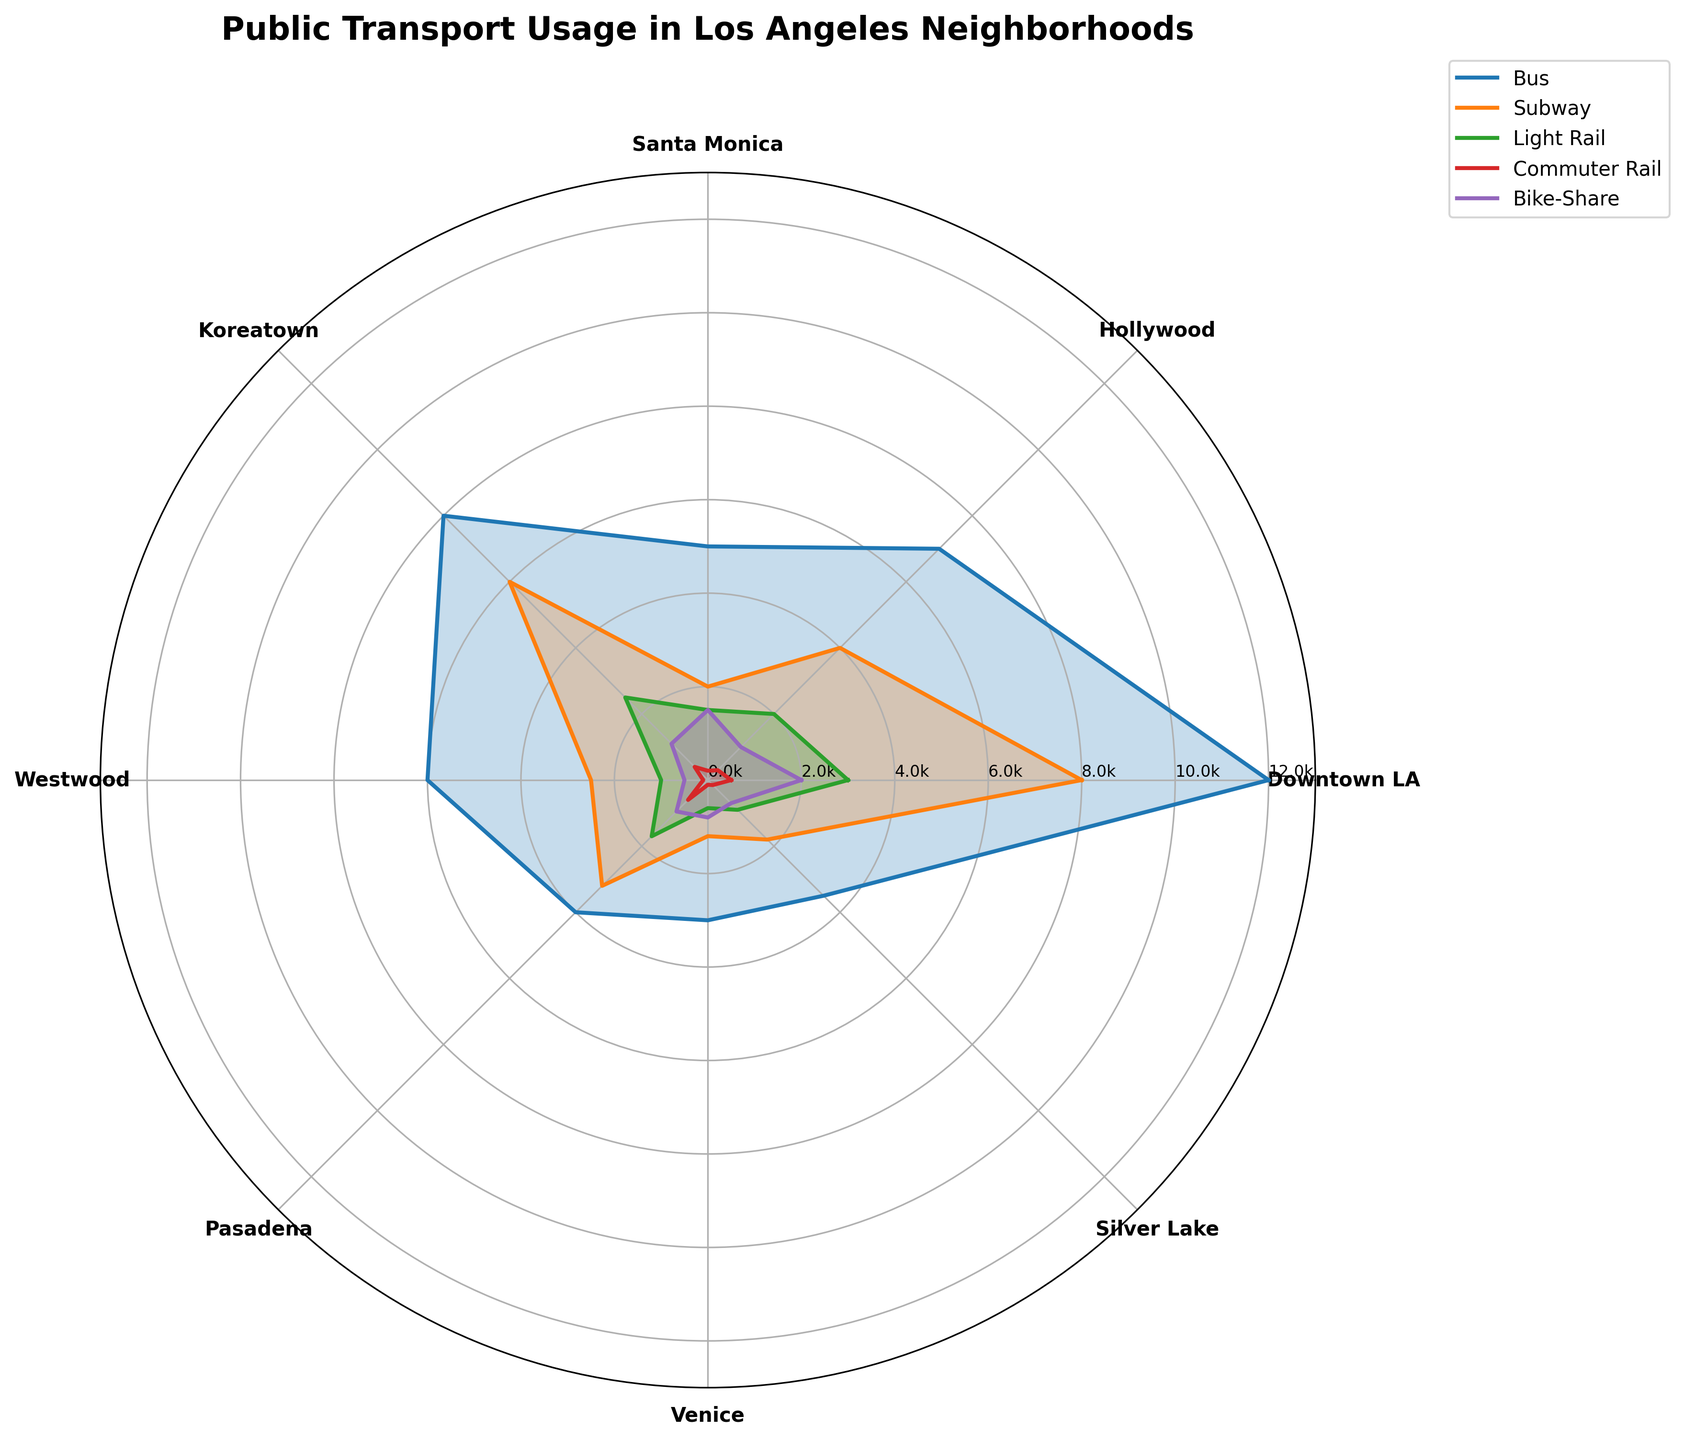What is the title of the polar area chart? The title of the chart is prominently displayed at the top of the figure.
Answer: Public Transport Usage in Los Angeles Neighborhoods Which neighborhood has the highest Bus usage? To find the neighborhood with the highest bus usage, look at the length of the corresponding radial line for 'Bus' in each neighborhood.
Answer: Downtown LA How does Bike-Share usage in Santa Monica compare to Venice? Compare the length of the radial lines for 'Bike-Share' usage in Santa Monica and Venice.
Answer: Santa Monica has higher Bike-Share usage than Venice What are the transport modes represented in the chart? Identify the labels present in the legend to determine the transport modes.
Answer: Bus, Subway, Light Rail, Commuter Rail, Bike-Share Which neighborhood has the lowest Subway usage? Look for the shortest radial line for 'Subway' across all neighborhoods.
Answer: Venice How does total public transport usage in Koreatown compare to Westwood? Sum the values of all transport modes for Koreatown and Westwood, then compare them.
Answer: Koreatown has higher total public transport usage than Westwood What is the maximum value represented for any transport mode in any neighborhood? Identify the longest radial line in the entire chart, which represents the highest individual value.
Answer: 12000 Which neighborhood has the highest overall public transport usage, summing all modes? Calculate the sum of all transport modes for each neighborhood and determine the highest.
Answer: Downtown LA How many neighborhoods are represented in the chart? Count the number of unique neighborhood labels around the circumference of the polar plot.
Answer: 8 Which neighborhood has the shortest Commuter Rail usage line? Look for the shortest radial line for 'Commuter Rail' across all neighborhoods.
Answer: Venice 